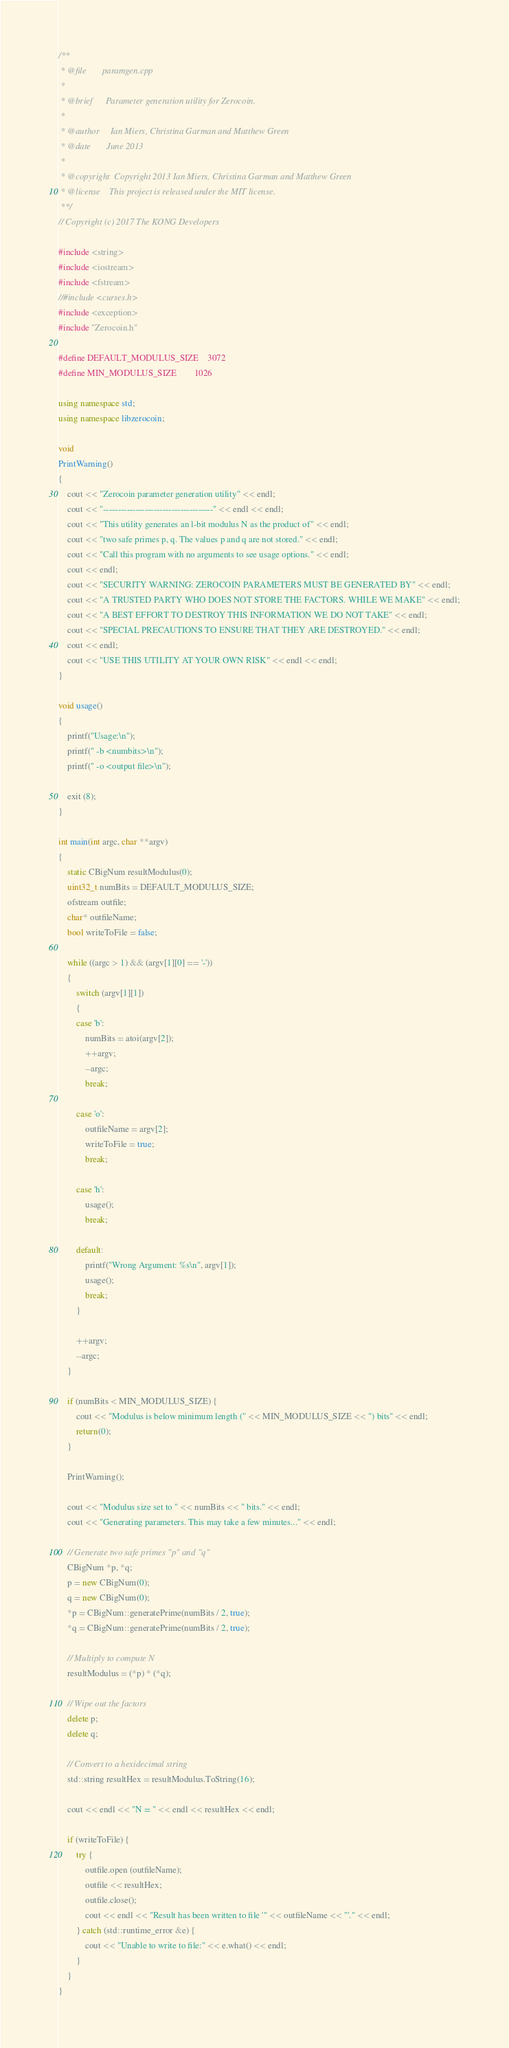<code> <loc_0><loc_0><loc_500><loc_500><_C++_>/**
 * @file       paramgen.cpp
 *
 * @brief      Parameter generation utility for Zerocoin.
 *
 * @author     Ian Miers, Christina Garman and Matthew Green
 * @date       June 2013
 *
 * @copyright  Copyright 2013 Ian Miers, Christina Garman and Matthew Green
 * @license    This project is released under the MIT license.
 **/
// Copyright (c) 2017 The KONG Developers 

#include <string>
#include <iostream>
#include <fstream>
//#include <curses.h>
#include <exception>
#include "Zerocoin.h"

#define DEFAULT_MODULUS_SIZE    3072
#define MIN_MODULUS_SIZE        1026

using namespace std;
using namespace libzerocoin;

void
PrintWarning()
{
	cout << "Zerocoin parameter generation utility" << endl;
	cout << "-------------------------------------" << endl << endl;
	cout << "This utility generates an l-bit modulus N as the product of" << endl;
	cout << "two safe primes p, q. The values p and q are not stored." << endl;
	cout << "Call this program with no arguments to see usage options." << endl;
	cout << endl;
	cout << "SECURITY WARNING: ZEROCOIN PARAMETERS MUST BE GENERATED BY" << endl;
	cout << "A TRUSTED PARTY WHO DOES NOT STORE THE FACTORS. WHILE WE MAKE" << endl;
	cout << "A BEST EFFORT TO DESTROY THIS INFORMATION WE DO NOT TAKE" << endl;
	cout << "SPECIAL PRECAUTIONS TO ENSURE THAT THEY ARE DESTROYED." << endl;
	cout << endl;
	cout << "USE THIS UTILITY AT YOUR OWN RISK" << endl << endl;
}

void usage()
{
	printf("Usage:\n");
	printf(" -b <numbits>\n");
	printf(" -o <output file>\n");

	exit (8);
}

int main(int argc, char **argv)
{
	static CBigNum resultModulus(0);
	uint32_t numBits = DEFAULT_MODULUS_SIZE;
	ofstream outfile;
	char* outfileName;
	bool writeToFile = false;

	while ((argc > 1) && (argv[1][0] == '-'))
	{
		switch (argv[1][1])
		{
		case 'b':
			numBits = atoi(argv[2]);
			++argv;
			--argc;
			break;

		case 'o':
			outfileName = argv[2];
			writeToFile = true;
			break;

		case 'h':
			usage();
			break;

		default:
			printf("Wrong Argument: %s\n", argv[1]);
			usage();
			break;
		}

		++argv;
		--argc;
	}

	if (numBits < MIN_MODULUS_SIZE) {
		cout << "Modulus is below minimum length (" << MIN_MODULUS_SIZE << ") bits" << endl;
		return(0);
	}

	PrintWarning();

	cout << "Modulus size set to " << numBits << " bits." << endl;
	cout << "Generating parameters. This may take a few minutes..." << endl;

	// Generate two safe primes "p" and "q"
	CBigNum *p, *q;
	p = new CBigNum(0);
	q = new CBigNum(0);
	*p = CBigNum::generatePrime(numBits / 2, true);
	*q = CBigNum::generatePrime(numBits / 2, true);

	// Multiply to compute N
	resultModulus = (*p) * (*q);

	// Wipe out the factors
	delete p;
	delete q;

	// Convert to a hexidecimal string
	std::string resultHex = resultModulus.ToString(16);

	cout << endl << "N = " << endl << resultHex << endl;

	if (writeToFile) {
		try {
			outfile.open (outfileName);
			outfile << resultHex;
			outfile.close();
			cout << endl << "Result has been written to file '" << outfileName << "'." << endl;
		} catch (std::runtime_error &e) {
			cout << "Unable to write to file:" << e.what() << endl;
		}
	}
}
</code> 